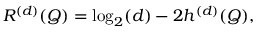Convert formula to latex. <formula><loc_0><loc_0><loc_500><loc_500>\begin{array} { r } { R ^ { ( d ) } ( Q ) = \log _ { 2 } ( d ) - 2 h ^ { ( d ) } ( Q ) , } \end{array}</formula> 